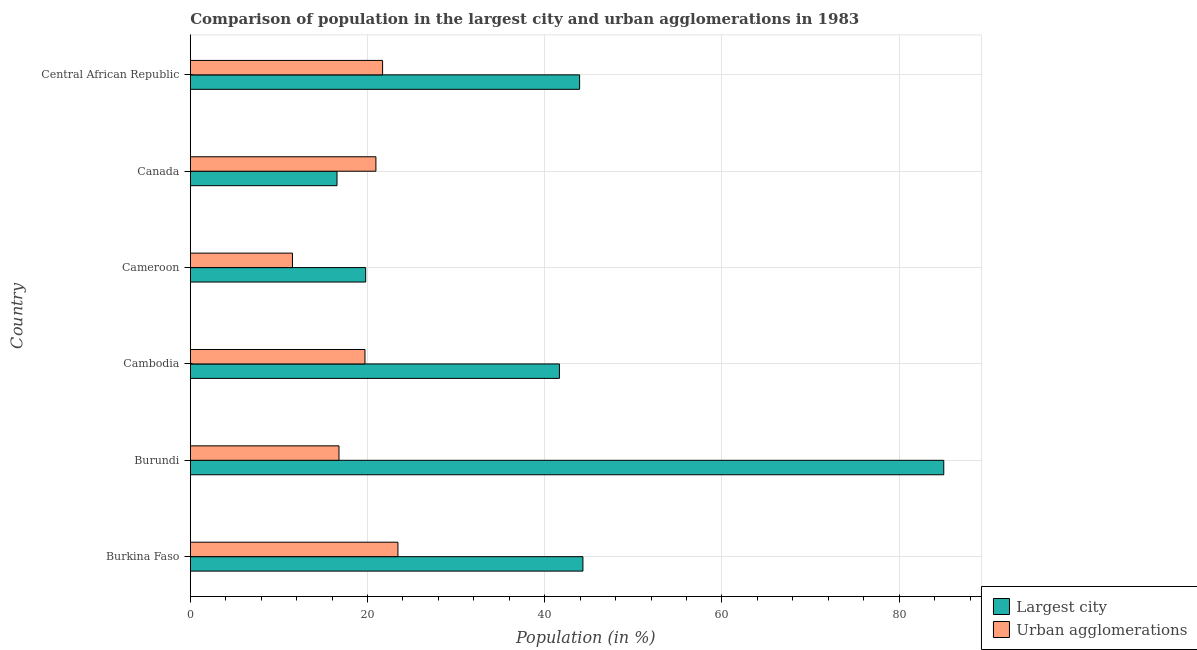How many groups of bars are there?
Your response must be concise. 6. Are the number of bars on each tick of the Y-axis equal?
Your response must be concise. Yes. How many bars are there on the 5th tick from the top?
Keep it short and to the point. 2. How many bars are there on the 5th tick from the bottom?
Ensure brevity in your answer.  2. In how many cases, is the number of bars for a given country not equal to the number of legend labels?
Offer a terse response. 0. What is the population in the largest city in Central African Republic?
Provide a short and direct response. 43.94. Across all countries, what is the maximum population in the largest city?
Keep it short and to the point. 85.04. Across all countries, what is the minimum population in the largest city?
Offer a terse response. 16.56. In which country was the population in the largest city maximum?
Ensure brevity in your answer.  Burundi. In which country was the population in the largest city minimum?
Your answer should be compact. Canada. What is the total population in urban agglomerations in the graph?
Offer a terse response. 114.11. What is the difference between the population in urban agglomerations in Burkina Faso and that in Cambodia?
Ensure brevity in your answer.  3.72. What is the difference between the population in urban agglomerations in Central African Republic and the population in the largest city in Canada?
Offer a very short reply. 5.14. What is the average population in the largest city per country?
Offer a terse response. 41.88. What is the difference between the population in the largest city and population in urban agglomerations in Central African Republic?
Provide a succinct answer. 22.23. In how many countries, is the population in the largest city greater than 56 %?
Your answer should be compact. 1. What is the ratio of the population in the largest city in Burundi to that in Central African Republic?
Keep it short and to the point. 1.94. Is the difference between the population in the largest city in Cambodia and Central African Republic greater than the difference between the population in urban agglomerations in Cambodia and Central African Republic?
Your answer should be compact. No. What is the difference between the highest and the second highest population in the largest city?
Offer a terse response. 40.73. What is the difference between the highest and the lowest population in the largest city?
Offer a terse response. 68.48. In how many countries, is the population in the largest city greater than the average population in the largest city taken over all countries?
Give a very brief answer. 3. What does the 1st bar from the top in Cameroon represents?
Give a very brief answer. Urban agglomerations. What does the 1st bar from the bottom in Cameroon represents?
Offer a terse response. Largest city. How many bars are there?
Make the answer very short. 12. Does the graph contain any zero values?
Provide a succinct answer. No. Does the graph contain grids?
Make the answer very short. Yes. How are the legend labels stacked?
Ensure brevity in your answer.  Vertical. What is the title of the graph?
Provide a succinct answer. Comparison of population in the largest city and urban agglomerations in 1983. What is the label or title of the X-axis?
Your response must be concise. Population (in %). What is the Population (in %) of Largest city in Burkina Faso?
Your answer should be compact. 44.31. What is the Population (in %) of Urban agglomerations in Burkina Faso?
Offer a very short reply. 23.43. What is the Population (in %) in Largest city in Burundi?
Keep it short and to the point. 85.04. What is the Population (in %) of Urban agglomerations in Burundi?
Make the answer very short. 16.78. What is the Population (in %) in Largest city in Cambodia?
Ensure brevity in your answer.  41.66. What is the Population (in %) of Urban agglomerations in Cambodia?
Offer a terse response. 19.71. What is the Population (in %) of Largest city in Cameroon?
Provide a succinct answer. 19.79. What is the Population (in %) of Urban agglomerations in Cameroon?
Make the answer very short. 11.53. What is the Population (in %) of Largest city in Canada?
Offer a terse response. 16.56. What is the Population (in %) of Urban agglomerations in Canada?
Your answer should be very brief. 20.95. What is the Population (in %) of Largest city in Central African Republic?
Offer a terse response. 43.94. What is the Population (in %) in Urban agglomerations in Central African Republic?
Offer a very short reply. 21.7. Across all countries, what is the maximum Population (in %) in Largest city?
Offer a very short reply. 85.04. Across all countries, what is the maximum Population (in %) in Urban agglomerations?
Ensure brevity in your answer.  23.43. Across all countries, what is the minimum Population (in %) in Largest city?
Your response must be concise. 16.56. Across all countries, what is the minimum Population (in %) of Urban agglomerations?
Ensure brevity in your answer.  11.53. What is the total Population (in %) in Largest city in the graph?
Provide a short and direct response. 251.3. What is the total Population (in %) of Urban agglomerations in the graph?
Keep it short and to the point. 114.11. What is the difference between the Population (in %) of Largest city in Burkina Faso and that in Burundi?
Keep it short and to the point. -40.73. What is the difference between the Population (in %) in Urban agglomerations in Burkina Faso and that in Burundi?
Your response must be concise. 6.65. What is the difference between the Population (in %) of Largest city in Burkina Faso and that in Cambodia?
Give a very brief answer. 2.65. What is the difference between the Population (in %) in Urban agglomerations in Burkina Faso and that in Cambodia?
Ensure brevity in your answer.  3.72. What is the difference between the Population (in %) in Largest city in Burkina Faso and that in Cameroon?
Offer a terse response. 24.52. What is the difference between the Population (in %) in Urban agglomerations in Burkina Faso and that in Cameroon?
Keep it short and to the point. 11.9. What is the difference between the Population (in %) in Largest city in Burkina Faso and that in Canada?
Offer a very short reply. 27.75. What is the difference between the Population (in %) in Urban agglomerations in Burkina Faso and that in Canada?
Offer a very short reply. 2.49. What is the difference between the Population (in %) of Largest city in Burkina Faso and that in Central African Republic?
Provide a succinct answer. 0.37. What is the difference between the Population (in %) in Urban agglomerations in Burkina Faso and that in Central African Republic?
Make the answer very short. 1.73. What is the difference between the Population (in %) in Largest city in Burundi and that in Cambodia?
Offer a very short reply. 43.38. What is the difference between the Population (in %) of Urban agglomerations in Burundi and that in Cambodia?
Provide a short and direct response. -2.93. What is the difference between the Population (in %) of Largest city in Burundi and that in Cameroon?
Your answer should be very brief. 65.25. What is the difference between the Population (in %) of Urban agglomerations in Burundi and that in Cameroon?
Ensure brevity in your answer.  5.25. What is the difference between the Population (in %) in Largest city in Burundi and that in Canada?
Provide a short and direct response. 68.48. What is the difference between the Population (in %) of Urban agglomerations in Burundi and that in Canada?
Provide a succinct answer. -4.17. What is the difference between the Population (in %) in Largest city in Burundi and that in Central African Republic?
Your response must be concise. 41.1. What is the difference between the Population (in %) in Urban agglomerations in Burundi and that in Central African Republic?
Provide a succinct answer. -4.92. What is the difference between the Population (in %) of Largest city in Cambodia and that in Cameroon?
Provide a short and direct response. 21.87. What is the difference between the Population (in %) in Urban agglomerations in Cambodia and that in Cameroon?
Keep it short and to the point. 8.18. What is the difference between the Population (in %) in Largest city in Cambodia and that in Canada?
Give a very brief answer. 25.1. What is the difference between the Population (in %) of Urban agglomerations in Cambodia and that in Canada?
Keep it short and to the point. -1.23. What is the difference between the Population (in %) in Largest city in Cambodia and that in Central African Republic?
Keep it short and to the point. -2.28. What is the difference between the Population (in %) in Urban agglomerations in Cambodia and that in Central African Republic?
Offer a very short reply. -1.99. What is the difference between the Population (in %) in Largest city in Cameroon and that in Canada?
Keep it short and to the point. 3.23. What is the difference between the Population (in %) of Urban agglomerations in Cameroon and that in Canada?
Ensure brevity in your answer.  -9.42. What is the difference between the Population (in %) in Largest city in Cameroon and that in Central African Republic?
Keep it short and to the point. -24.15. What is the difference between the Population (in %) in Urban agglomerations in Cameroon and that in Central African Republic?
Provide a short and direct response. -10.17. What is the difference between the Population (in %) of Largest city in Canada and that in Central African Republic?
Offer a terse response. -27.38. What is the difference between the Population (in %) in Urban agglomerations in Canada and that in Central African Republic?
Keep it short and to the point. -0.76. What is the difference between the Population (in %) in Largest city in Burkina Faso and the Population (in %) in Urban agglomerations in Burundi?
Make the answer very short. 27.53. What is the difference between the Population (in %) of Largest city in Burkina Faso and the Population (in %) of Urban agglomerations in Cambodia?
Your response must be concise. 24.6. What is the difference between the Population (in %) of Largest city in Burkina Faso and the Population (in %) of Urban agglomerations in Cameroon?
Your response must be concise. 32.78. What is the difference between the Population (in %) of Largest city in Burkina Faso and the Population (in %) of Urban agglomerations in Canada?
Your response must be concise. 23.36. What is the difference between the Population (in %) in Largest city in Burkina Faso and the Population (in %) in Urban agglomerations in Central African Republic?
Ensure brevity in your answer.  22.61. What is the difference between the Population (in %) in Largest city in Burundi and the Population (in %) in Urban agglomerations in Cambodia?
Offer a very short reply. 65.33. What is the difference between the Population (in %) in Largest city in Burundi and the Population (in %) in Urban agglomerations in Cameroon?
Your response must be concise. 73.51. What is the difference between the Population (in %) in Largest city in Burundi and the Population (in %) in Urban agglomerations in Canada?
Offer a very short reply. 64.09. What is the difference between the Population (in %) in Largest city in Burundi and the Population (in %) in Urban agglomerations in Central African Republic?
Your response must be concise. 63.34. What is the difference between the Population (in %) of Largest city in Cambodia and the Population (in %) of Urban agglomerations in Cameroon?
Keep it short and to the point. 30.13. What is the difference between the Population (in %) in Largest city in Cambodia and the Population (in %) in Urban agglomerations in Canada?
Provide a succinct answer. 20.71. What is the difference between the Population (in %) of Largest city in Cambodia and the Population (in %) of Urban agglomerations in Central African Republic?
Your answer should be compact. 19.96. What is the difference between the Population (in %) in Largest city in Cameroon and the Population (in %) in Urban agglomerations in Canada?
Keep it short and to the point. -1.15. What is the difference between the Population (in %) in Largest city in Cameroon and the Population (in %) in Urban agglomerations in Central African Republic?
Your answer should be compact. -1.91. What is the difference between the Population (in %) of Largest city in Canada and the Population (in %) of Urban agglomerations in Central African Republic?
Make the answer very short. -5.14. What is the average Population (in %) in Largest city per country?
Provide a succinct answer. 41.88. What is the average Population (in %) in Urban agglomerations per country?
Provide a short and direct response. 19.02. What is the difference between the Population (in %) in Largest city and Population (in %) in Urban agglomerations in Burkina Faso?
Provide a succinct answer. 20.88. What is the difference between the Population (in %) in Largest city and Population (in %) in Urban agglomerations in Burundi?
Your response must be concise. 68.26. What is the difference between the Population (in %) of Largest city and Population (in %) of Urban agglomerations in Cambodia?
Provide a succinct answer. 21.95. What is the difference between the Population (in %) in Largest city and Population (in %) in Urban agglomerations in Cameroon?
Make the answer very short. 8.26. What is the difference between the Population (in %) of Largest city and Population (in %) of Urban agglomerations in Canada?
Your response must be concise. -4.39. What is the difference between the Population (in %) in Largest city and Population (in %) in Urban agglomerations in Central African Republic?
Make the answer very short. 22.24. What is the ratio of the Population (in %) in Largest city in Burkina Faso to that in Burundi?
Provide a short and direct response. 0.52. What is the ratio of the Population (in %) of Urban agglomerations in Burkina Faso to that in Burundi?
Keep it short and to the point. 1.4. What is the ratio of the Population (in %) of Largest city in Burkina Faso to that in Cambodia?
Your answer should be very brief. 1.06. What is the ratio of the Population (in %) of Urban agglomerations in Burkina Faso to that in Cambodia?
Offer a terse response. 1.19. What is the ratio of the Population (in %) in Largest city in Burkina Faso to that in Cameroon?
Your response must be concise. 2.24. What is the ratio of the Population (in %) in Urban agglomerations in Burkina Faso to that in Cameroon?
Your answer should be very brief. 2.03. What is the ratio of the Population (in %) of Largest city in Burkina Faso to that in Canada?
Make the answer very short. 2.68. What is the ratio of the Population (in %) of Urban agglomerations in Burkina Faso to that in Canada?
Your answer should be compact. 1.12. What is the ratio of the Population (in %) of Largest city in Burkina Faso to that in Central African Republic?
Give a very brief answer. 1.01. What is the ratio of the Population (in %) in Urban agglomerations in Burkina Faso to that in Central African Republic?
Offer a terse response. 1.08. What is the ratio of the Population (in %) of Largest city in Burundi to that in Cambodia?
Offer a terse response. 2.04. What is the ratio of the Population (in %) in Urban agglomerations in Burundi to that in Cambodia?
Provide a succinct answer. 0.85. What is the ratio of the Population (in %) of Largest city in Burundi to that in Cameroon?
Offer a very short reply. 4.3. What is the ratio of the Population (in %) in Urban agglomerations in Burundi to that in Cameroon?
Give a very brief answer. 1.46. What is the ratio of the Population (in %) of Largest city in Burundi to that in Canada?
Your answer should be very brief. 5.14. What is the ratio of the Population (in %) of Urban agglomerations in Burundi to that in Canada?
Provide a succinct answer. 0.8. What is the ratio of the Population (in %) in Largest city in Burundi to that in Central African Republic?
Your response must be concise. 1.94. What is the ratio of the Population (in %) in Urban agglomerations in Burundi to that in Central African Republic?
Make the answer very short. 0.77. What is the ratio of the Population (in %) in Largest city in Cambodia to that in Cameroon?
Make the answer very short. 2.1. What is the ratio of the Population (in %) of Urban agglomerations in Cambodia to that in Cameroon?
Make the answer very short. 1.71. What is the ratio of the Population (in %) in Largest city in Cambodia to that in Canada?
Give a very brief answer. 2.52. What is the ratio of the Population (in %) in Urban agglomerations in Cambodia to that in Canada?
Offer a terse response. 0.94. What is the ratio of the Population (in %) in Largest city in Cambodia to that in Central African Republic?
Provide a short and direct response. 0.95. What is the ratio of the Population (in %) in Urban agglomerations in Cambodia to that in Central African Republic?
Ensure brevity in your answer.  0.91. What is the ratio of the Population (in %) of Largest city in Cameroon to that in Canada?
Your response must be concise. 1.2. What is the ratio of the Population (in %) in Urban agglomerations in Cameroon to that in Canada?
Your answer should be compact. 0.55. What is the ratio of the Population (in %) of Largest city in Cameroon to that in Central African Republic?
Make the answer very short. 0.45. What is the ratio of the Population (in %) of Urban agglomerations in Cameroon to that in Central African Republic?
Your response must be concise. 0.53. What is the ratio of the Population (in %) of Largest city in Canada to that in Central African Republic?
Ensure brevity in your answer.  0.38. What is the ratio of the Population (in %) in Urban agglomerations in Canada to that in Central African Republic?
Your answer should be very brief. 0.97. What is the difference between the highest and the second highest Population (in %) in Largest city?
Provide a succinct answer. 40.73. What is the difference between the highest and the second highest Population (in %) of Urban agglomerations?
Offer a terse response. 1.73. What is the difference between the highest and the lowest Population (in %) in Largest city?
Provide a succinct answer. 68.48. What is the difference between the highest and the lowest Population (in %) of Urban agglomerations?
Keep it short and to the point. 11.9. 